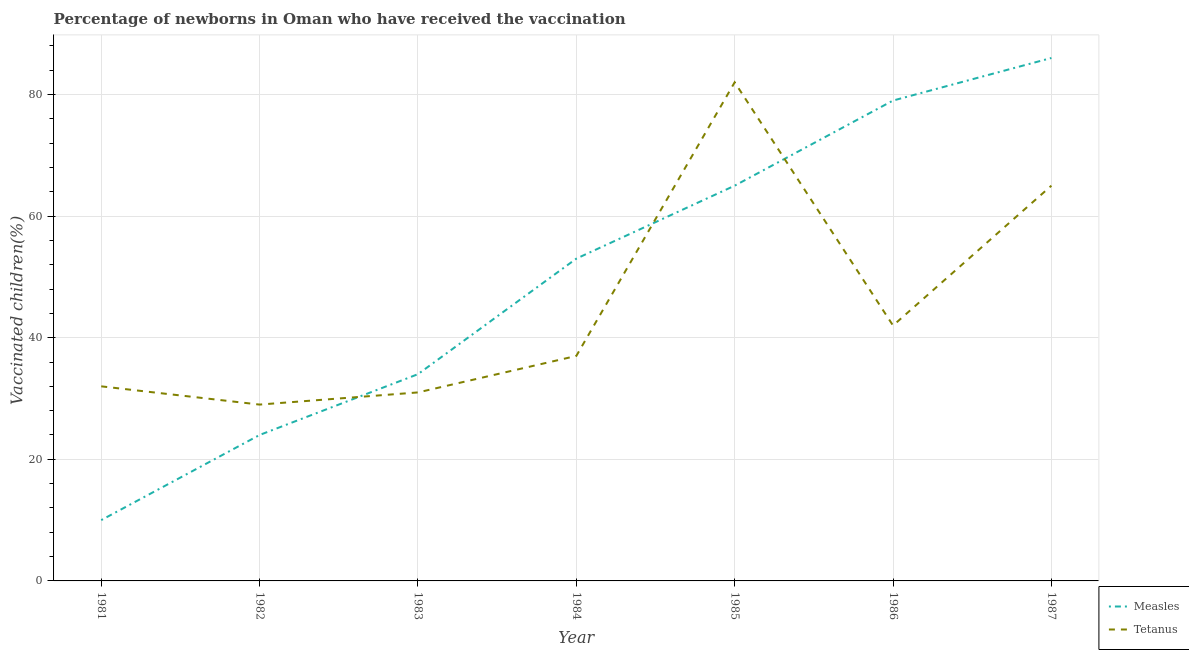Does the line corresponding to percentage of newborns who received vaccination for measles intersect with the line corresponding to percentage of newborns who received vaccination for tetanus?
Offer a terse response. Yes. What is the percentage of newborns who received vaccination for tetanus in 1985?
Offer a very short reply. 82. Across all years, what is the maximum percentage of newborns who received vaccination for tetanus?
Offer a terse response. 82. Across all years, what is the minimum percentage of newborns who received vaccination for measles?
Make the answer very short. 10. In which year was the percentage of newborns who received vaccination for tetanus maximum?
Ensure brevity in your answer.  1985. In which year was the percentage of newborns who received vaccination for measles minimum?
Keep it short and to the point. 1981. What is the total percentage of newborns who received vaccination for measles in the graph?
Your answer should be compact. 351. What is the difference between the percentage of newborns who received vaccination for tetanus in 1981 and that in 1984?
Make the answer very short. -5. What is the difference between the percentage of newborns who received vaccination for tetanus in 1986 and the percentage of newborns who received vaccination for measles in 1987?
Your response must be concise. -44. What is the average percentage of newborns who received vaccination for measles per year?
Offer a terse response. 50.14. In the year 1981, what is the difference between the percentage of newborns who received vaccination for tetanus and percentage of newborns who received vaccination for measles?
Ensure brevity in your answer.  22. In how many years, is the percentage of newborns who received vaccination for tetanus greater than 20 %?
Your answer should be very brief. 7. What is the ratio of the percentage of newborns who received vaccination for tetanus in 1982 to that in 1983?
Keep it short and to the point. 0.94. Is the percentage of newborns who received vaccination for measles in 1981 less than that in 1984?
Your response must be concise. Yes. What is the difference between the highest and the second highest percentage of newborns who received vaccination for tetanus?
Make the answer very short. 17. What is the difference between the highest and the lowest percentage of newborns who received vaccination for measles?
Ensure brevity in your answer.  76. Is the percentage of newborns who received vaccination for measles strictly greater than the percentage of newborns who received vaccination for tetanus over the years?
Provide a short and direct response. No. What is the difference between two consecutive major ticks on the Y-axis?
Provide a short and direct response. 20. What is the title of the graph?
Offer a terse response. Percentage of newborns in Oman who have received the vaccination. What is the label or title of the Y-axis?
Make the answer very short. Vaccinated children(%)
. What is the Vaccinated children(%)
 in Tetanus in 1982?
Make the answer very short. 29. What is the Vaccinated children(%)
 in Tetanus in 1984?
Give a very brief answer. 37. What is the Vaccinated children(%)
 in Measles in 1986?
Ensure brevity in your answer.  79. What is the Vaccinated children(%)
 in Tetanus in 1986?
Make the answer very short. 42. Across all years, what is the maximum Vaccinated children(%)
 of Measles?
Give a very brief answer. 86. Across all years, what is the minimum Vaccinated children(%)
 in Measles?
Provide a short and direct response. 10. Across all years, what is the minimum Vaccinated children(%)
 in Tetanus?
Make the answer very short. 29. What is the total Vaccinated children(%)
 of Measles in the graph?
Provide a succinct answer. 351. What is the total Vaccinated children(%)
 of Tetanus in the graph?
Provide a succinct answer. 318. What is the difference between the Vaccinated children(%)
 in Measles in 1981 and that in 1983?
Keep it short and to the point. -24. What is the difference between the Vaccinated children(%)
 in Tetanus in 1981 and that in 1983?
Give a very brief answer. 1. What is the difference between the Vaccinated children(%)
 in Measles in 1981 and that in 1984?
Offer a very short reply. -43. What is the difference between the Vaccinated children(%)
 of Measles in 1981 and that in 1985?
Ensure brevity in your answer.  -55. What is the difference between the Vaccinated children(%)
 in Tetanus in 1981 and that in 1985?
Keep it short and to the point. -50. What is the difference between the Vaccinated children(%)
 in Measles in 1981 and that in 1986?
Your response must be concise. -69. What is the difference between the Vaccinated children(%)
 in Tetanus in 1981 and that in 1986?
Offer a very short reply. -10. What is the difference between the Vaccinated children(%)
 of Measles in 1981 and that in 1987?
Your answer should be very brief. -76. What is the difference between the Vaccinated children(%)
 in Tetanus in 1981 and that in 1987?
Make the answer very short. -33. What is the difference between the Vaccinated children(%)
 in Tetanus in 1982 and that in 1983?
Provide a short and direct response. -2. What is the difference between the Vaccinated children(%)
 in Measles in 1982 and that in 1984?
Your answer should be compact. -29. What is the difference between the Vaccinated children(%)
 in Measles in 1982 and that in 1985?
Keep it short and to the point. -41. What is the difference between the Vaccinated children(%)
 in Tetanus in 1982 and that in 1985?
Give a very brief answer. -53. What is the difference between the Vaccinated children(%)
 in Measles in 1982 and that in 1986?
Give a very brief answer. -55. What is the difference between the Vaccinated children(%)
 of Measles in 1982 and that in 1987?
Your answer should be compact. -62. What is the difference between the Vaccinated children(%)
 in Tetanus in 1982 and that in 1987?
Give a very brief answer. -36. What is the difference between the Vaccinated children(%)
 of Measles in 1983 and that in 1984?
Ensure brevity in your answer.  -19. What is the difference between the Vaccinated children(%)
 of Tetanus in 1983 and that in 1984?
Offer a terse response. -6. What is the difference between the Vaccinated children(%)
 of Measles in 1983 and that in 1985?
Your answer should be very brief. -31. What is the difference between the Vaccinated children(%)
 in Tetanus in 1983 and that in 1985?
Your response must be concise. -51. What is the difference between the Vaccinated children(%)
 in Measles in 1983 and that in 1986?
Give a very brief answer. -45. What is the difference between the Vaccinated children(%)
 of Measles in 1983 and that in 1987?
Keep it short and to the point. -52. What is the difference between the Vaccinated children(%)
 in Tetanus in 1983 and that in 1987?
Your response must be concise. -34. What is the difference between the Vaccinated children(%)
 in Measles in 1984 and that in 1985?
Make the answer very short. -12. What is the difference between the Vaccinated children(%)
 of Tetanus in 1984 and that in 1985?
Provide a succinct answer. -45. What is the difference between the Vaccinated children(%)
 of Measles in 1984 and that in 1987?
Provide a short and direct response. -33. What is the difference between the Vaccinated children(%)
 in Measles in 1985 and that in 1986?
Ensure brevity in your answer.  -14. What is the difference between the Vaccinated children(%)
 in Measles in 1985 and that in 1987?
Keep it short and to the point. -21. What is the difference between the Vaccinated children(%)
 in Measles in 1986 and that in 1987?
Offer a terse response. -7. What is the difference between the Vaccinated children(%)
 of Measles in 1981 and the Vaccinated children(%)
 of Tetanus in 1982?
Your response must be concise. -19. What is the difference between the Vaccinated children(%)
 in Measles in 1981 and the Vaccinated children(%)
 in Tetanus in 1983?
Offer a terse response. -21. What is the difference between the Vaccinated children(%)
 of Measles in 1981 and the Vaccinated children(%)
 of Tetanus in 1984?
Keep it short and to the point. -27. What is the difference between the Vaccinated children(%)
 in Measles in 1981 and the Vaccinated children(%)
 in Tetanus in 1985?
Provide a short and direct response. -72. What is the difference between the Vaccinated children(%)
 in Measles in 1981 and the Vaccinated children(%)
 in Tetanus in 1986?
Offer a terse response. -32. What is the difference between the Vaccinated children(%)
 of Measles in 1981 and the Vaccinated children(%)
 of Tetanus in 1987?
Keep it short and to the point. -55. What is the difference between the Vaccinated children(%)
 of Measles in 1982 and the Vaccinated children(%)
 of Tetanus in 1983?
Make the answer very short. -7. What is the difference between the Vaccinated children(%)
 of Measles in 1982 and the Vaccinated children(%)
 of Tetanus in 1985?
Keep it short and to the point. -58. What is the difference between the Vaccinated children(%)
 in Measles in 1982 and the Vaccinated children(%)
 in Tetanus in 1987?
Offer a terse response. -41. What is the difference between the Vaccinated children(%)
 in Measles in 1983 and the Vaccinated children(%)
 in Tetanus in 1984?
Make the answer very short. -3. What is the difference between the Vaccinated children(%)
 in Measles in 1983 and the Vaccinated children(%)
 in Tetanus in 1985?
Your answer should be very brief. -48. What is the difference between the Vaccinated children(%)
 of Measles in 1983 and the Vaccinated children(%)
 of Tetanus in 1986?
Offer a terse response. -8. What is the difference between the Vaccinated children(%)
 in Measles in 1983 and the Vaccinated children(%)
 in Tetanus in 1987?
Provide a succinct answer. -31. What is the difference between the Vaccinated children(%)
 in Measles in 1984 and the Vaccinated children(%)
 in Tetanus in 1985?
Ensure brevity in your answer.  -29. What is the difference between the Vaccinated children(%)
 in Measles in 1984 and the Vaccinated children(%)
 in Tetanus in 1986?
Keep it short and to the point. 11. What is the difference between the Vaccinated children(%)
 in Measles in 1985 and the Vaccinated children(%)
 in Tetanus in 1986?
Your answer should be compact. 23. What is the average Vaccinated children(%)
 in Measles per year?
Your answer should be very brief. 50.14. What is the average Vaccinated children(%)
 of Tetanus per year?
Your response must be concise. 45.43. In the year 1984, what is the difference between the Vaccinated children(%)
 in Measles and Vaccinated children(%)
 in Tetanus?
Ensure brevity in your answer.  16. In the year 1986, what is the difference between the Vaccinated children(%)
 in Measles and Vaccinated children(%)
 in Tetanus?
Your answer should be compact. 37. What is the ratio of the Vaccinated children(%)
 in Measles in 1981 to that in 1982?
Provide a succinct answer. 0.42. What is the ratio of the Vaccinated children(%)
 in Tetanus in 1981 to that in 1982?
Offer a terse response. 1.1. What is the ratio of the Vaccinated children(%)
 in Measles in 1981 to that in 1983?
Keep it short and to the point. 0.29. What is the ratio of the Vaccinated children(%)
 of Tetanus in 1981 to that in 1983?
Keep it short and to the point. 1.03. What is the ratio of the Vaccinated children(%)
 in Measles in 1981 to that in 1984?
Give a very brief answer. 0.19. What is the ratio of the Vaccinated children(%)
 in Tetanus in 1981 to that in 1984?
Make the answer very short. 0.86. What is the ratio of the Vaccinated children(%)
 in Measles in 1981 to that in 1985?
Make the answer very short. 0.15. What is the ratio of the Vaccinated children(%)
 of Tetanus in 1981 to that in 1985?
Keep it short and to the point. 0.39. What is the ratio of the Vaccinated children(%)
 of Measles in 1981 to that in 1986?
Offer a terse response. 0.13. What is the ratio of the Vaccinated children(%)
 of Tetanus in 1981 to that in 1986?
Provide a short and direct response. 0.76. What is the ratio of the Vaccinated children(%)
 in Measles in 1981 to that in 1987?
Give a very brief answer. 0.12. What is the ratio of the Vaccinated children(%)
 in Tetanus in 1981 to that in 1987?
Your answer should be compact. 0.49. What is the ratio of the Vaccinated children(%)
 in Measles in 1982 to that in 1983?
Make the answer very short. 0.71. What is the ratio of the Vaccinated children(%)
 in Tetanus in 1982 to that in 1983?
Give a very brief answer. 0.94. What is the ratio of the Vaccinated children(%)
 in Measles in 1982 to that in 1984?
Give a very brief answer. 0.45. What is the ratio of the Vaccinated children(%)
 in Tetanus in 1982 to that in 1984?
Provide a short and direct response. 0.78. What is the ratio of the Vaccinated children(%)
 of Measles in 1982 to that in 1985?
Give a very brief answer. 0.37. What is the ratio of the Vaccinated children(%)
 of Tetanus in 1982 to that in 1985?
Keep it short and to the point. 0.35. What is the ratio of the Vaccinated children(%)
 in Measles in 1982 to that in 1986?
Make the answer very short. 0.3. What is the ratio of the Vaccinated children(%)
 of Tetanus in 1982 to that in 1986?
Give a very brief answer. 0.69. What is the ratio of the Vaccinated children(%)
 in Measles in 1982 to that in 1987?
Your response must be concise. 0.28. What is the ratio of the Vaccinated children(%)
 in Tetanus in 1982 to that in 1987?
Make the answer very short. 0.45. What is the ratio of the Vaccinated children(%)
 in Measles in 1983 to that in 1984?
Provide a succinct answer. 0.64. What is the ratio of the Vaccinated children(%)
 in Tetanus in 1983 to that in 1984?
Your answer should be compact. 0.84. What is the ratio of the Vaccinated children(%)
 of Measles in 1983 to that in 1985?
Provide a succinct answer. 0.52. What is the ratio of the Vaccinated children(%)
 of Tetanus in 1983 to that in 1985?
Your response must be concise. 0.38. What is the ratio of the Vaccinated children(%)
 in Measles in 1983 to that in 1986?
Ensure brevity in your answer.  0.43. What is the ratio of the Vaccinated children(%)
 in Tetanus in 1983 to that in 1986?
Give a very brief answer. 0.74. What is the ratio of the Vaccinated children(%)
 of Measles in 1983 to that in 1987?
Give a very brief answer. 0.4. What is the ratio of the Vaccinated children(%)
 in Tetanus in 1983 to that in 1987?
Your response must be concise. 0.48. What is the ratio of the Vaccinated children(%)
 in Measles in 1984 to that in 1985?
Keep it short and to the point. 0.82. What is the ratio of the Vaccinated children(%)
 in Tetanus in 1984 to that in 1985?
Give a very brief answer. 0.45. What is the ratio of the Vaccinated children(%)
 in Measles in 1984 to that in 1986?
Your answer should be compact. 0.67. What is the ratio of the Vaccinated children(%)
 of Tetanus in 1984 to that in 1986?
Provide a succinct answer. 0.88. What is the ratio of the Vaccinated children(%)
 in Measles in 1984 to that in 1987?
Provide a short and direct response. 0.62. What is the ratio of the Vaccinated children(%)
 of Tetanus in 1984 to that in 1987?
Offer a terse response. 0.57. What is the ratio of the Vaccinated children(%)
 of Measles in 1985 to that in 1986?
Your answer should be compact. 0.82. What is the ratio of the Vaccinated children(%)
 of Tetanus in 1985 to that in 1986?
Give a very brief answer. 1.95. What is the ratio of the Vaccinated children(%)
 in Measles in 1985 to that in 1987?
Offer a very short reply. 0.76. What is the ratio of the Vaccinated children(%)
 in Tetanus in 1985 to that in 1987?
Keep it short and to the point. 1.26. What is the ratio of the Vaccinated children(%)
 of Measles in 1986 to that in 1987?
Provide a succinct answer. 0.92. What is the ratio of the Vaccinated children(%)
 in Tetanus in 1986 to that in 1987?
Your answer should be compact. 0.65. What is the difference between the highest and the second highest Vaccinated children(%)
 of Measles?
Your answer should be compact. 7. What is the difference between the highest and the lowest Vaccinated children(%)
 of Tetanus?
Provide a succinct answer. 53. 